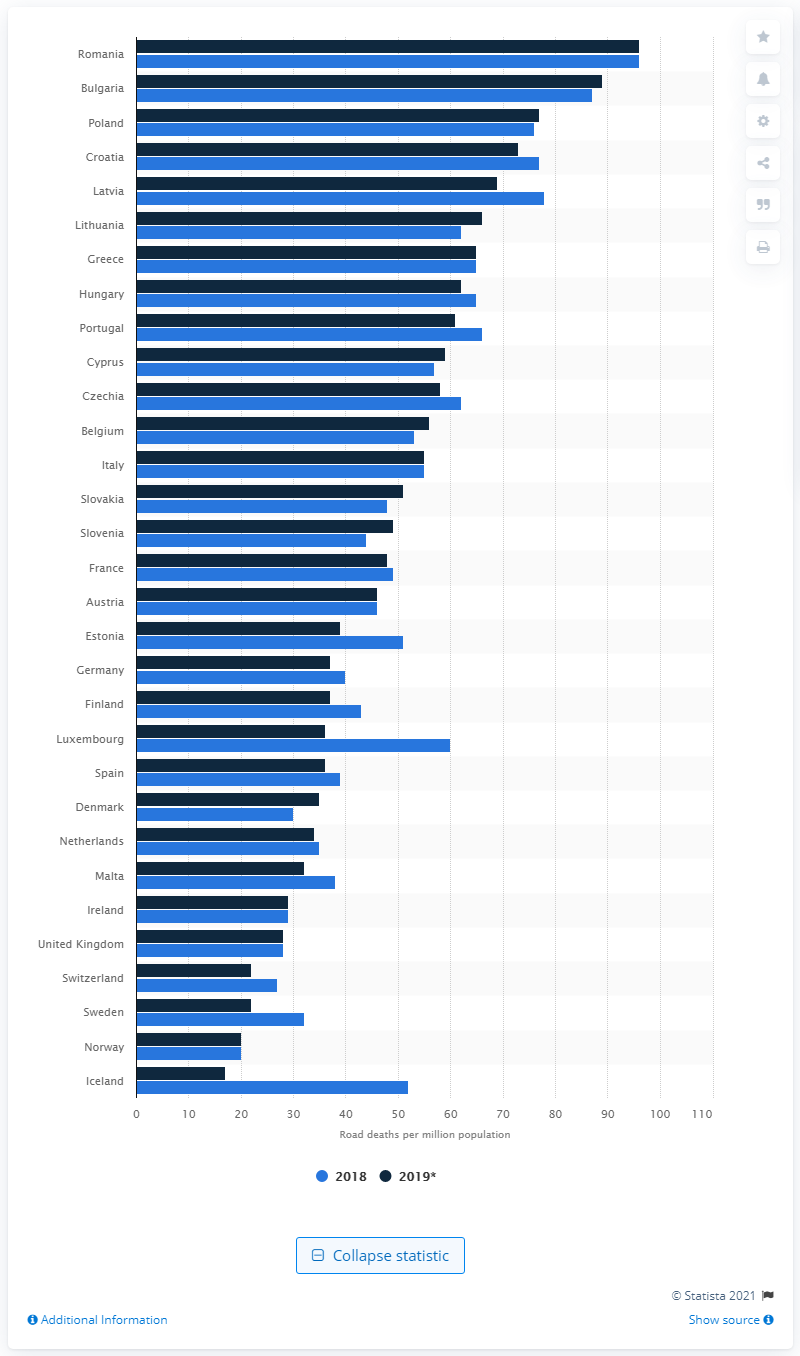Identify some key points in this picture. In 2019, the lowest death rate was recorded in Iceland. Sweden has the lowest rate of road fatalities in the European Union, according to recent data. 